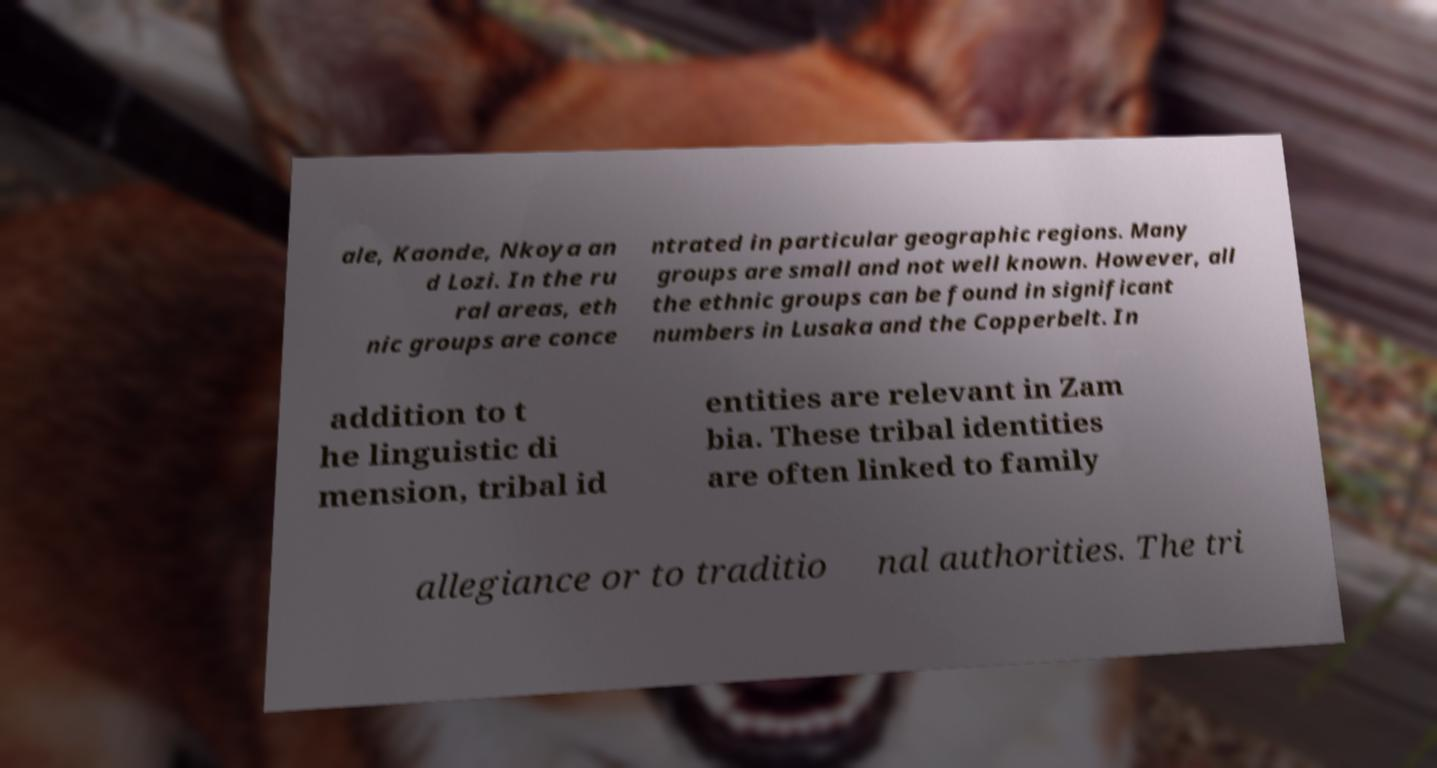Could you assist in decoding the text presented in this image and type it out clearly? ale, Kaonde, Nkoya an d Lozi. In the ru ral areas, eth nic groups are conce ntrated in particular geographic regions. Many groups are small and not well known. However, all the ethnic groups can be found in significant numbers in Lusaka and the Copperbelt. In addition to t he linguistic di mension, tribal id entities are relevant in Zam bia. These tribal identities are often linked to family allegiance or to traditio nal authorities. The tri 